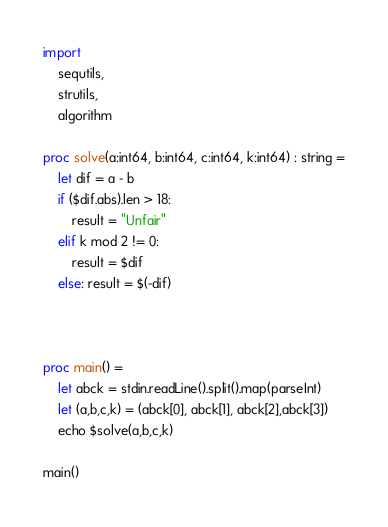Convert code to text. <code><loc_0><loc_0><loc_500><loc_500><_Nim_>import
    sequtils,
    strutils,
    algorithm

proc solve(a:int64, b:int64, c:int64, k:int64) : string =
    let dif = a - b
    if ($dif.abs).len > 18:
        result = "Unfair"
    elif k mod 2 != 0:
        result = $dif
    else: result = $(-dif)
    
        

proc main() =
    let abck = stdin.readLine().split().map(parseInt)
    let (a,b,c,k) = (abck[0], abck[1], abck[2],abck[3])
    echo $solve(a,b,c,k)
    
main()</code> 